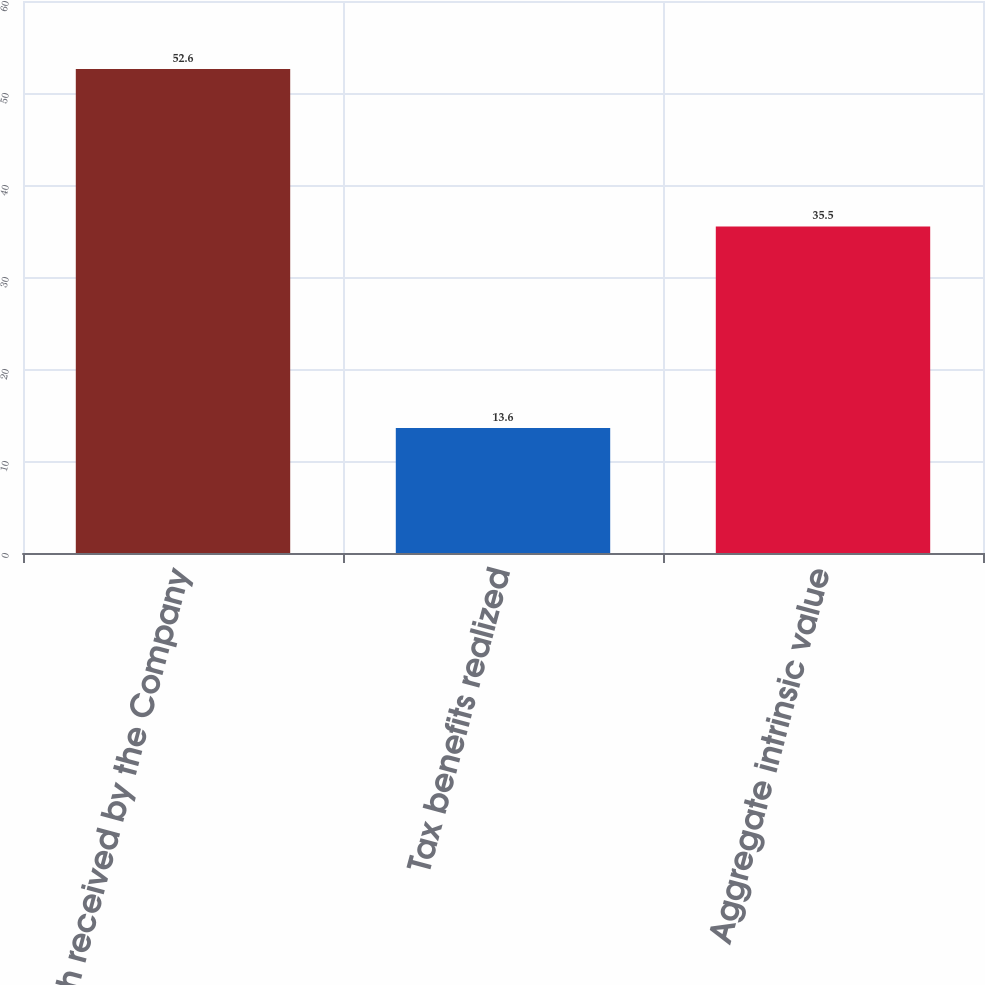<chart> <loc_0><loc_0><loc_500><loc_500><bar_chart><fcel>Cash received by the Company<fcel>Tax benefits realized<fcel>Aggregate intrinsic value<nl><fcel>52.6<fcel>13.6<fcel>35.5<nl></chart> 